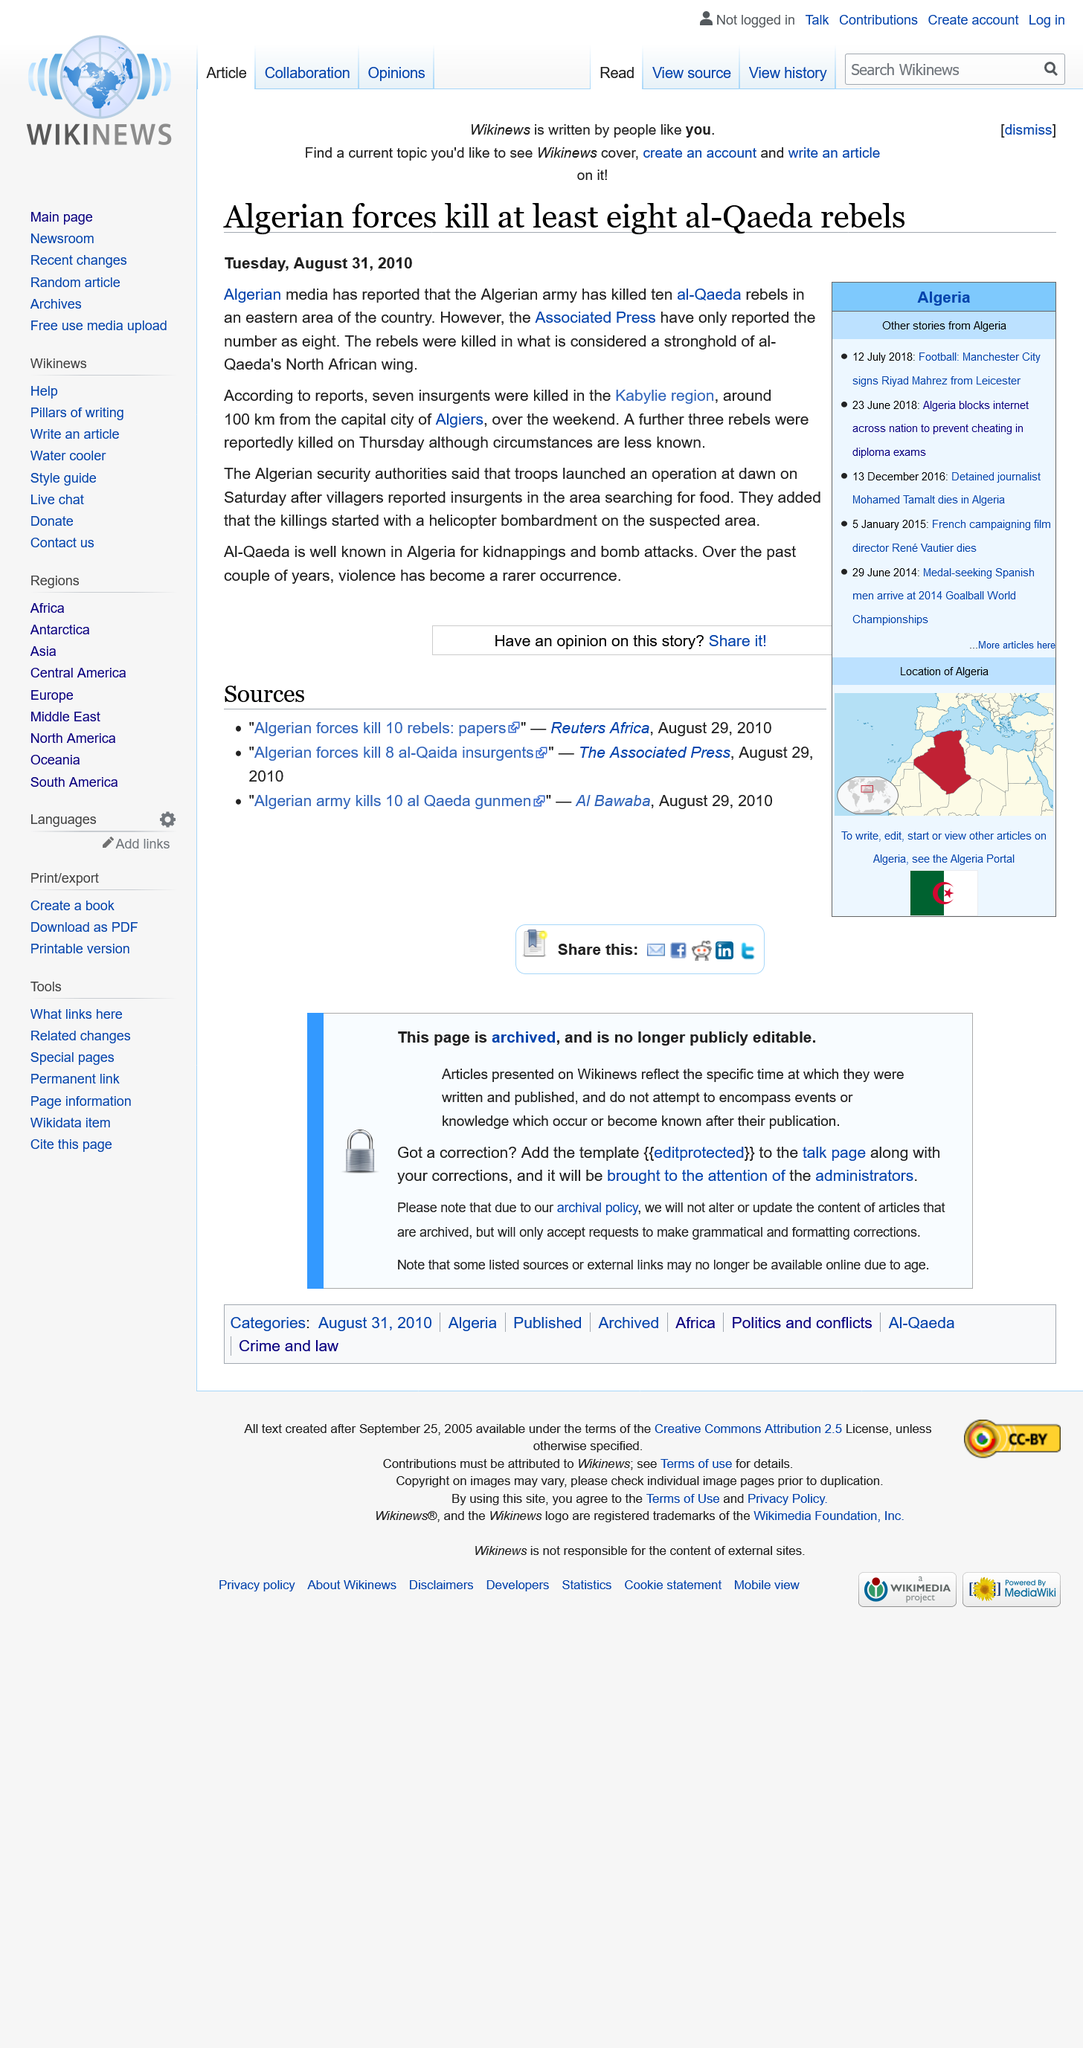Highlight a few significant elements in this photo. According to the article, Al-Qaeda is widely recognized in Algeria for its involvement in kidnappings and bomb attacks. Seven insurgents were reportedly killed in the Kabylie region, according to reports. I am a language model and do not have the ability to browse the internet, so I cannot provide the date of the article. 